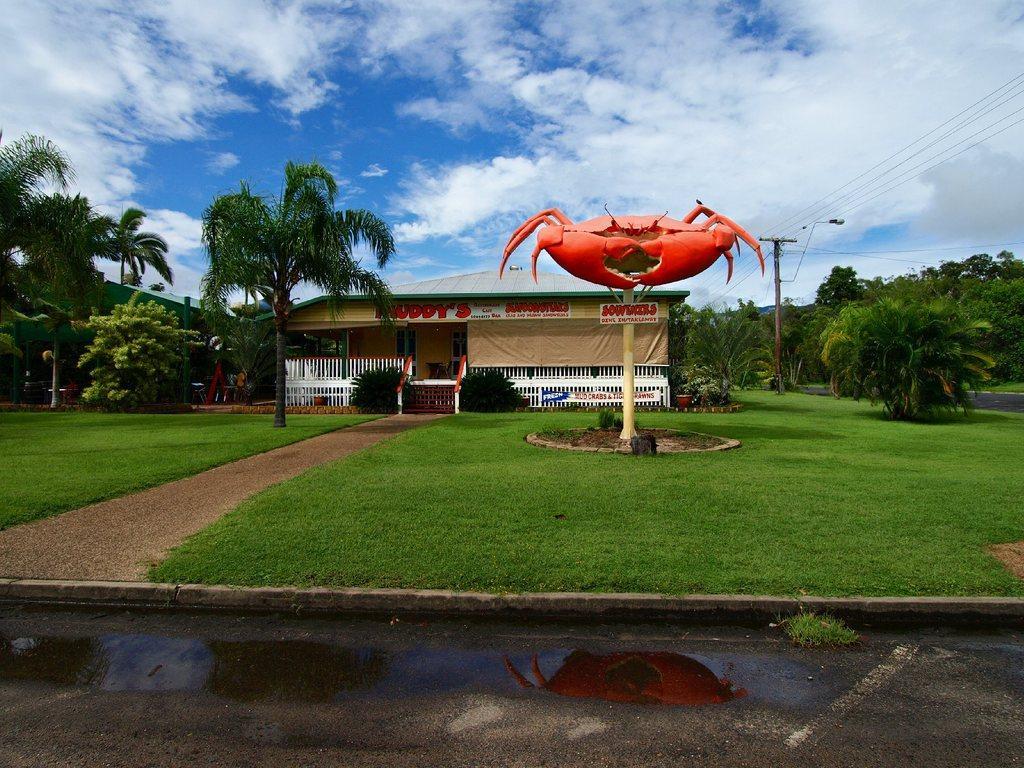In one or two sentences, can you explain what this image depicts? In this image there is the sky towards the top of the image, there are clouds in the sky, there are clouds in the sky, there is a building, there are boards, there is text on the boards, there is a streetlight, there are wires towards the right of the image, there are trees towards the right of the image, there are trees towards the left of the image, there is grass, there is a pole, there is a board on the pole, there is text on the pole, there is an object that looks like an insect, there is road towards the bottom of the image, there is water on the road. 